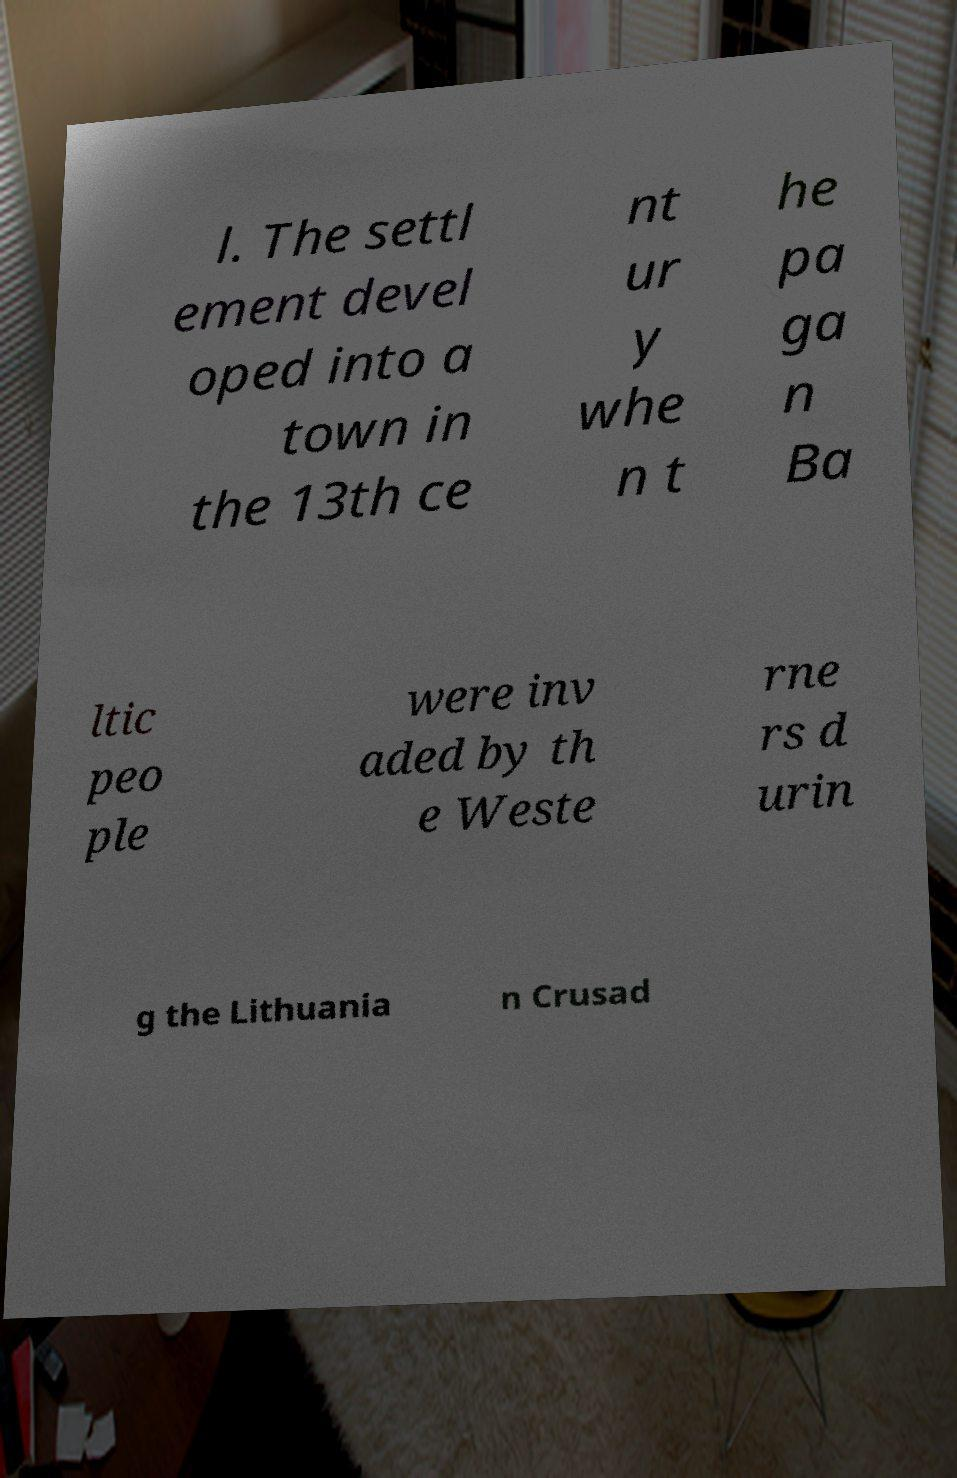Can you read and provide the text displayed in the image?This photo seems to have some interesting text. Can you extract and type it out for me? l. The settl ement devel oped into a town in the 13th ce nt ur y whe n t he pa ga n Ba ltic peo ple were inv aded by th e Weste rne rs d urin g the Lithuania n Crusad 